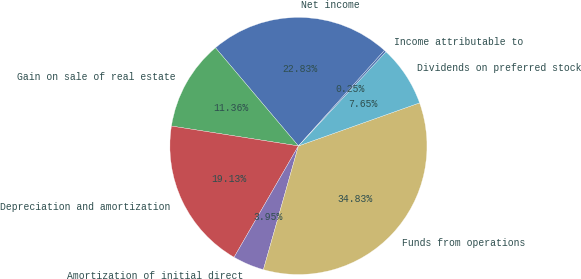Convert chart. <chart><loc_0><loc_0><loc_500><loc_500><pie_chart><fcel>Net income<fcel>Gain on sale of real estate<fcel>Depreciation and amortization<fcel>Amortization of initial direct<fcel>Funds from operations<fcel>Dividends on preferred stock<fcel>Income attributable to<nl><fcel>22.83%<fcel>11.36%<fcel>19.13%<fcel>3.95%<fcel>34.83%<fcel>7.65%<fcel>0.25%<nl></chart> 